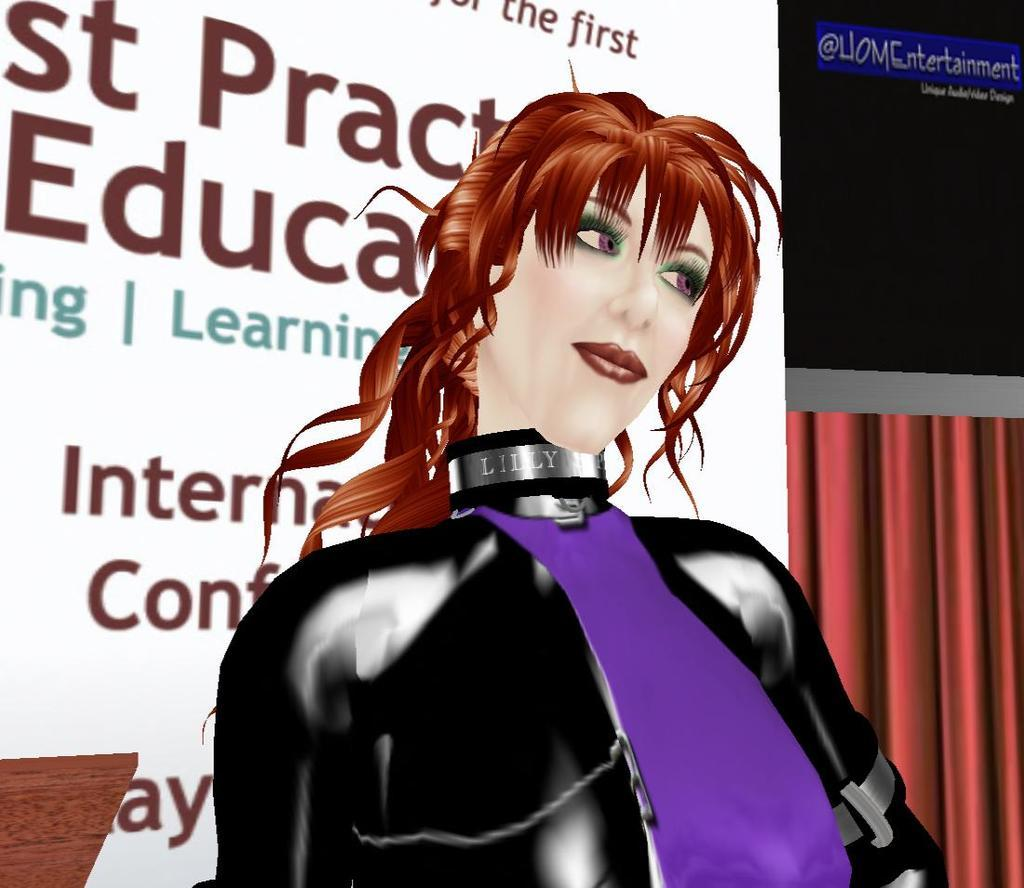What type of image is being described? The image is animated. Who or what is the main focus of the image? There is a lady in the center of the image. What can be seen in the background of the image? There is text and a curtain in the background of the image. What type of apparatus is being used by the lady in the image? There is no specific apparatus being used by the lady in the image; she is simply standing in the center. 